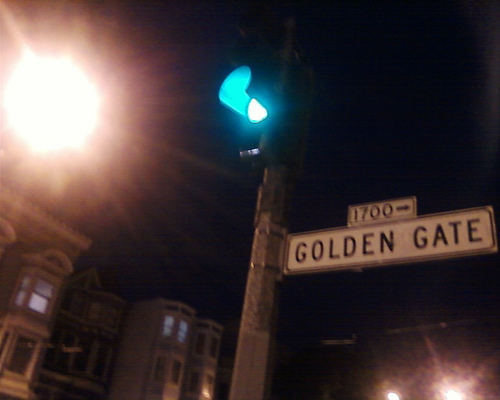<image>What black of Golden Gate street is this picture of? I am not sure what block of Golden Gate street is pictured. It can be seen 1700.
 What black of Golden Gate street is this picture of? I don't know what block of Golden Gate street this picture is of. It can be block 1700 or unknown. 